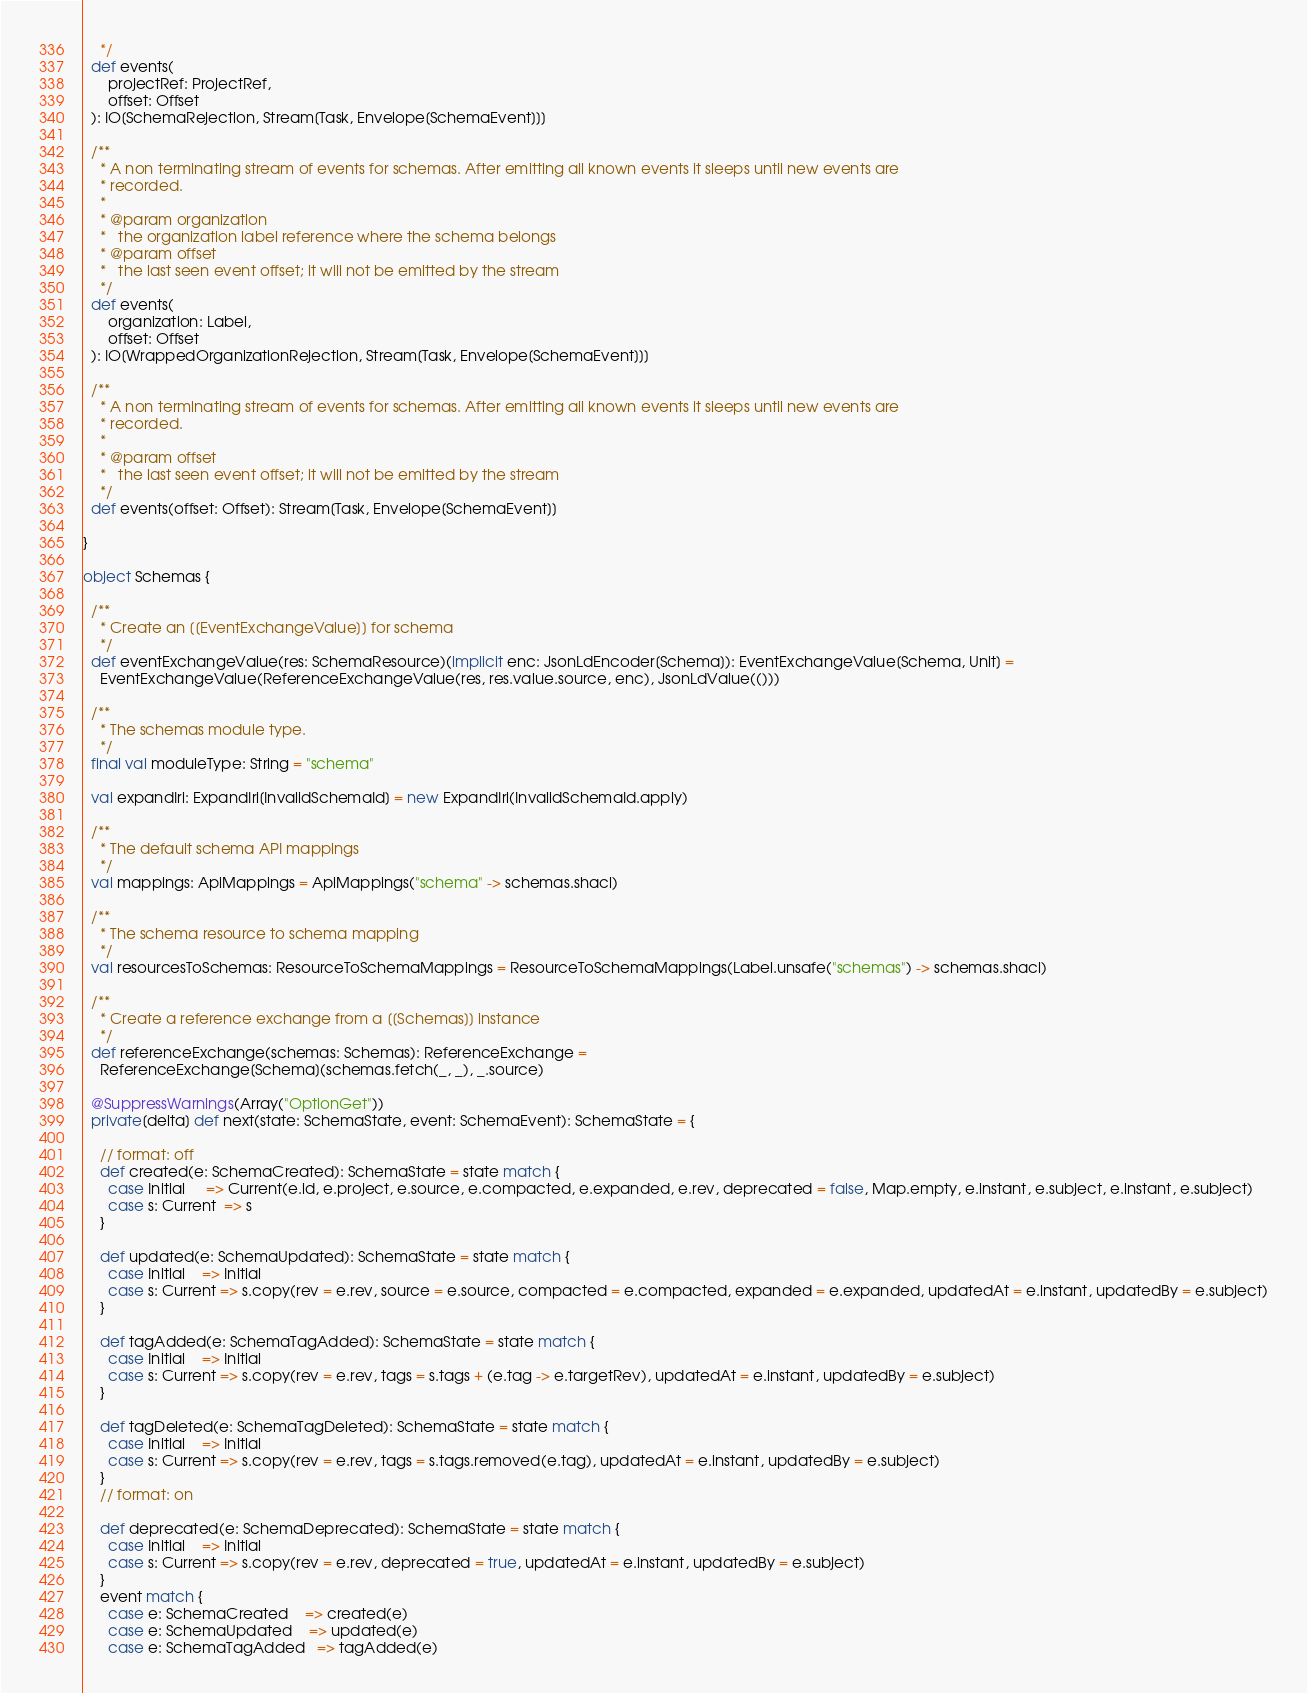Convert code to text. <code><loc_0><loc_0><loc_500><loc_500><_Scala_>    */
  def events(
      projectRef: ProjectRef,
      offset: Offset
  ): IO[SchemaRejection, Stream[Task, Envelope[SchemaEvent]]]

  /**
    * A non terminating stream of events for schemas. After emitting all known events it sleeps until new events are
    * recorded.
    *
    * @param organization
    *   the organization label reference where the schema belongs
    * @param offset
    *   the last seen event offset; it will not be emitted by the stream
    */
  def events(
      organization: Label,
      offset: Offset
  ): IO[WrappedOrganizationRejection, Stream[Task, Envelope[SchemaEvent]]]

  /**
    * A non terminating stream of events for schemas. After emitting all known events it sleeps until new events are
    * recorded.
    *
    * @param offset
    *   the last seen event offset; it will not be emitted by the stream
    */
  def events(offset: Offset): Stream[Task, Envelope[SchemaEvent]]

}

object Schemas {

  /**
    * Create an [[EventExchangeValue]] for schema
    */
  def eventExchangeValue(res: SchemaResource)(implicit enc: JsonLdEncoder[Schema]): EventExchangeValue[Schema, Unit] =
    EventExchangeValue(ReferenceExchangeValue(res, res.value.source, enc), JsonLdValue(()))

  /**
    * The schemas module type.
    */
  final val moduleType: String = "schema"

  val expandIri: ExpandIri[InvalidSchemaId] = new ExpandIri(InvalidSchemaId.apply)

  /**
    * The default schema API mappings
    */
  val mappings: ApiMappings = ApiMappings("schema" -> schemas.shacl)

  /**
    * The schema resource to schema mapping
    */
  val resourcesToSchemas: ResourceToSchemaMappings = ResourceToSchemaMappings(Label.unsafe("schemas") -> schemas.shacl)

  /**
    * Create a reference exchange from a [[Schemas]] instance
    */
  def referenceExchange(schemas: Schemas): ReferenceExchange =
    ReferenceExchange[Schema](schemas.fetch(_, _), _.source)

  @SuppressWarnings(Array("OptionGet"))
  private[delta] def next(state: SchemaState, event: SchemaEvent): SchemaState = {

    // format: off
    def created(e: SchemaCreated): SchemaState = state match {
      case Initial     => Current(e.id, e.project, e.source, e.compacted, e.expanded, e.rev, deprecated = false, Map.empty, e.instant, e.subject, e.instant, e.subject)
      case s: Current  => s
    }

    def updated(e: SchemaUpdated): SchemaState = state match {
      case Initial    => Initial
      case s: Current => s.copy(rev = e.rev, source = e.source, compacted = e.compacted, expanded = e.expanded, updatedAt = e.instant, updatedBy = e.subject)
    }

    def tagAdded(e: SchemaTagAdded): SchemaState = state match {
      case Initial    => Initial
      case s: Current => s.copy(rev = e.rev, tags = s.tags + (e.tag -> e.targetRev), updatedAt = e.instant, updatedBy = e.subject)
    }

    def tagDeleted(e: SchemaTagDeleted): SchemaState = state match {
      case Initial    => Initial
      case s: Current => s.copy(rev = e.rev, tags = s.tags.removed(e.tag), updatedAt = e.instant, updatedBy = e.subject)
    }
    // format: on

    def deprecated(e: SchemaDeprecated): SchemaState = state match {
      case Initial    => Initial
      case s: Current => s.copy(rev = e.rev, deprecated = true, updatedAt = e.instant, updatedBy = e.subject)
    }
    event match {
      case e: SchemaCreated    => created(e)
      case e: SchemaUpdated    => updated(e)
      case e: SchemaTagAdded   => tagAdded(e)</code> 